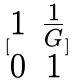<formula> <loc_0><loc_0><loc_500><loc_500>[ \begin{matrix} 1 & \frac { 1 } { G } \\ 0 & 1 \end{matrix} ]</formula> 